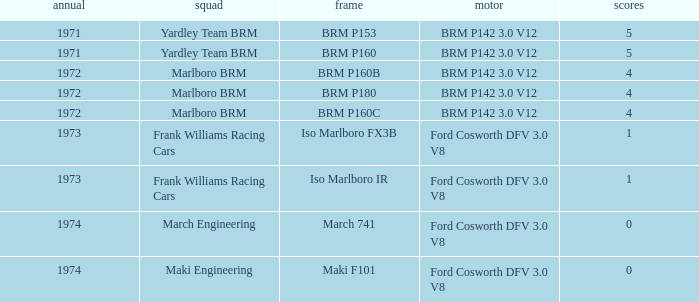What are the highest points for the team of marlboro brm with brm p180 as the chassis? 4.0. 